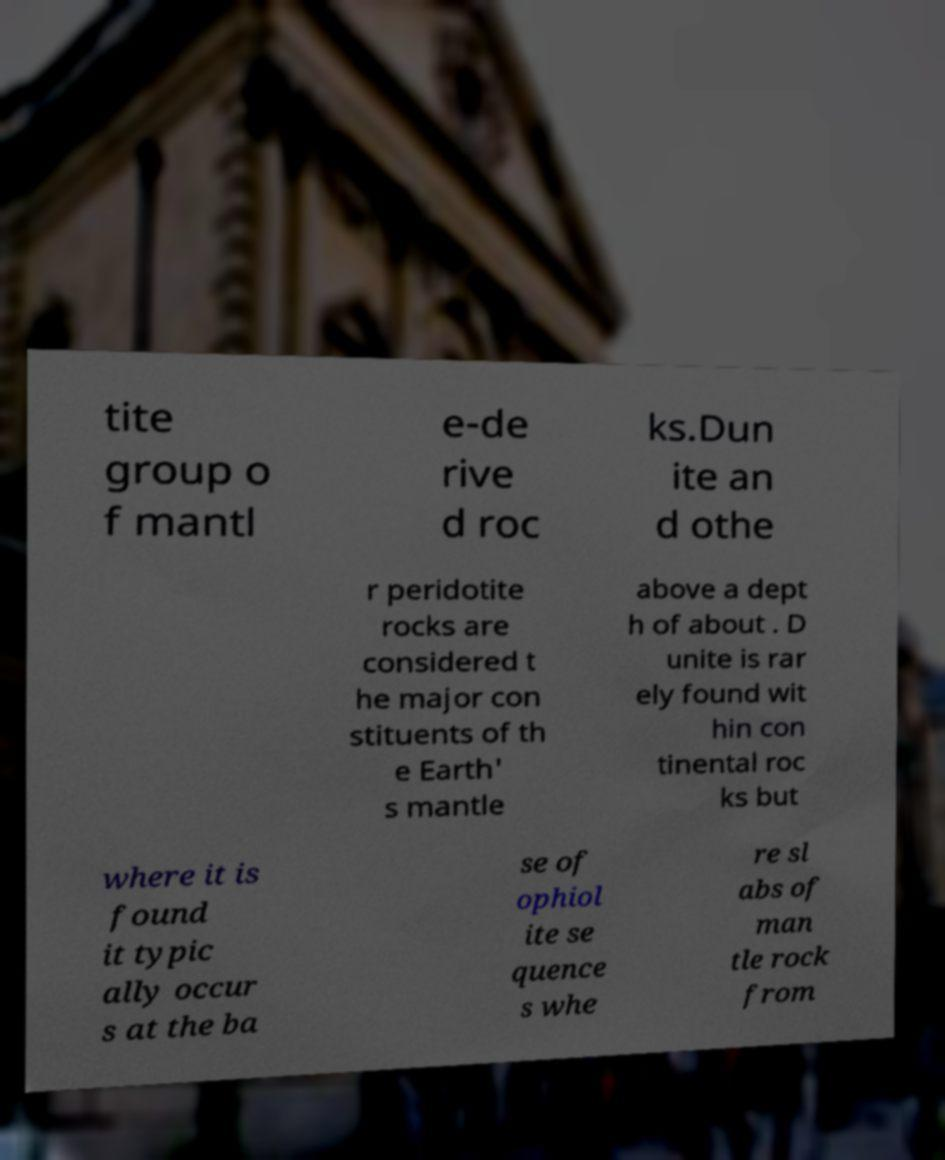Could you assist in decoding the text presented in this image and type it out clearly? tite group o f mantl e-de rive d roc ks.Dun ite an d othe r peridotite rocks are considered t he major con stituents of th e Earth' s mantle above a dept h of about . D unite is rar ely found wit hin con tinental roc ks but where it is found it typic ally occur s at the ba se of ophiol ite se quence s whe re sl abs of man tle rock from 